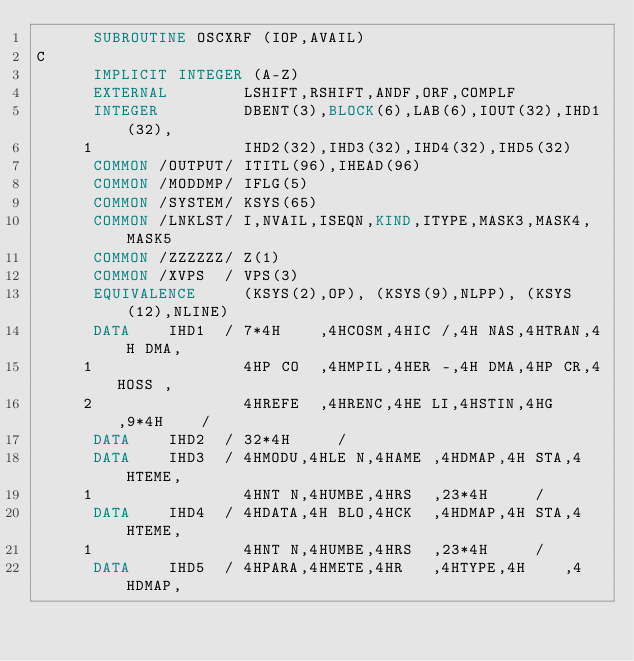<code> <loc_0><loc_0><loc_500><loc_500><_FORTRAN_>      SUBROUTINE OSCXRF (IOP,AVAIL)
C
      IMPLICIT INTEGER (A-Z)
      EXTERNAL        LSHIFT,RSHIFT,ANDF,ORF,COMPLF
      INTEGER         DBENT(3),BLOCK(6),LAB(6),IOUT(32),IHD1(32),
     1                IHD2(32),IHD3(32),IHD4(32),IHD5(32)
      COMMON /OUTPUT/ ITITL(96),IHEAD(96)
      COMMON /MODDMP/ IFLG(5)
      COMMON /SYSTEM/ KSYS(65)
      COMMON /LNKLST/ I,NVAIL,ISEQN,KIND,ITYPE,MASK3,MASK4,MASK5
      COMMON /ZZZZZZ/ Z(1)
      COMMON /XVPS  / VPS(3)
      EQUIVALENCE     (KSYS(2),OP), (KSYS(9),NLPP), (KSYS(12),NLINE)
      DATA    IHD1  / 7*4H    ,4HCOSM,4HIC /,4H NAS,4HTRAN,4H DMA,
     1                4HP CO  ,4HMPIL,4HER -,4H DMA,4HP CR,4HOSS ,
     2                4HREFE  ,4HRENC,4HE LI,4HSTIN,4HG   ,9*4H    /
      DATA    IHD2  / 32*4H     /
      DATA    IHD3  / 4HMODU,4HLE N,4HAME ,4HDMAP,4H STA,4HTEME,
     1                4HNT N,4HUMBE,4HRS  ,23*4H     /
      DATA    IHD4  / 4HDATA,4H BLO,4HCK  ,4HDMAP,4H STA,4HTEME,
     1                4HNT N,4HUMBE,4HRS  ,23*4H     /
      DATA    IHD5  / 4HPARA,4HMETE,4HR   ,4HTYPE,4H    ,4HDMAP,</code> 